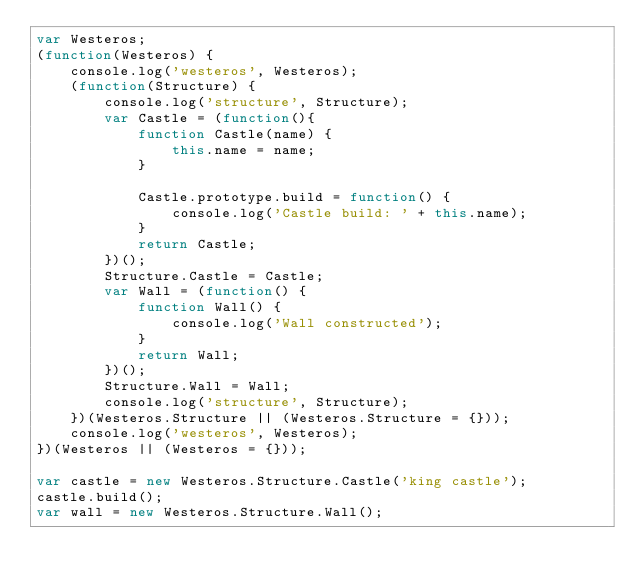Convert code to text. <code><loc_0><loc_0><loc_500><loc_500><_JavaScript_>var Westeros;
(function(Westeros) {
    console.log('westeros', Westeros);
    (function(Structure) {
        console.log('structure', Structure);
        var Castle = (function(){
            function Castle(name) {
                this.name = name;
            }

            Castle.prototype.build = function() {
                console.log('Castle build: ' + this.name);
            }
            return Castle;
        })();
        Structure.Castle = Castle;
        var Wall = (function() {
            function Wall() {
                console.log('Wall constructed');
            }
            return Wall;
        })();
        Structure.Wall = Wall;
        console.log('structure', Structure);        
    })(Westeros.Structure || (Westeros.Structure = {}));
    console.log('westeros', Westeros);    
})(Westeros || (Westeros = {}));

var castle = new Westeros.Structure.Castle('king castle');
castle.build();
var wall = new Westeros.Structure.Wall();</code> 